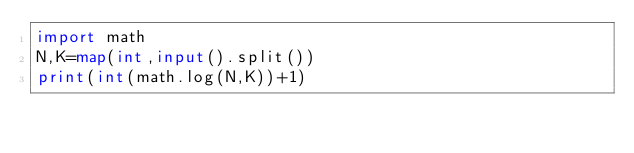Convert code to text. <code><loc_0><loc_0><loc_500><loc_500><_Python_>import math
N,K=map(int,input().split())
print(int(math.log(N,K))+1)</code> 